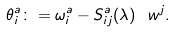<formula> <loc_0><loc_0><loc_500><loc_500>\theta _ { i } ^ { a } \colon = \omega ^ { a } _ { i } - S ^ { a } _ { i j } ( \lambda ) \ w ^ { j } .</formula> 